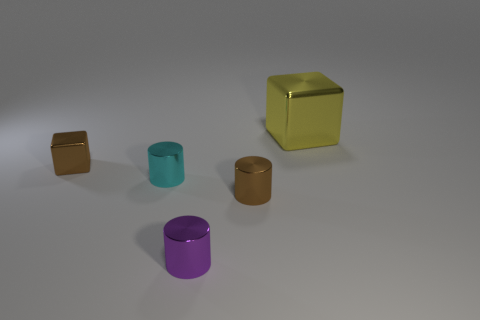Is the number of yellow things that are to the right of the yellow object less than the number of small red shiny objects?
Offer a terse response. No. The cube right of the cube in front of the large yellow thing behind the cyan cylinder is what color?
Provide a succinct answer. Yellow. How many metallic things are either tiny brown things or green objects?
Offer a terse response. 2. Do the cyan cylinder and the purple metal cylinder have the same size?
Your response must be concise. Yes. Are there fewer metallic cubes in front of the small purple metal cylinder than tiny brown blocks in front of the large yellow thing?
Make the answer very short. Yes. Is there any other thing that is the same size as the yellow block?
Your answer should be compact. No. The yellow cube has what size?
Provide a short and direct response. Large. What number of large objects are either red objects or brown objects?
Give a very brief answer. 0. There is a brown cylinder; does it have the same size as the block that is in front of the big metallic thing?
Ensure brevity in your answer.  Yes. What number of big rubber objects are there?
Make the answer very short. 0. 